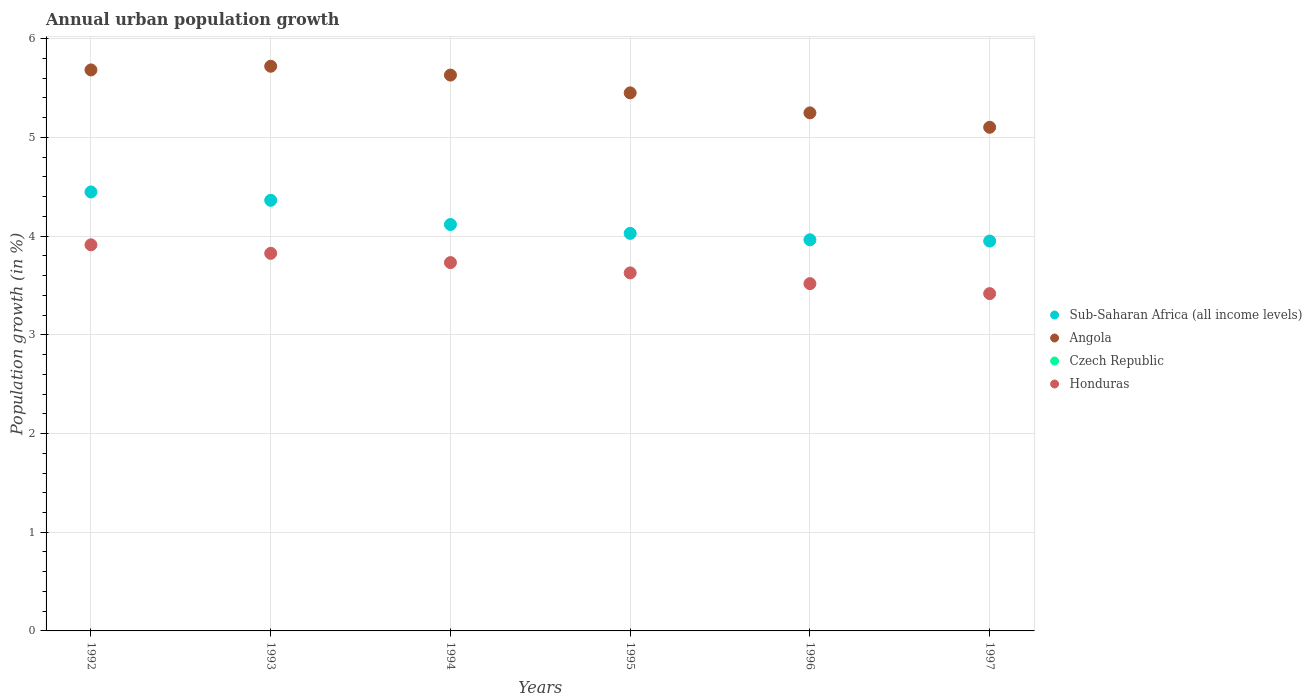Is the number of dotlines equal to the number of legend labels?
Offer a terse response. No. What is the percentage of urban population growth in Honduras in 1992?
Make the answer very short. 3.91. Across all years, what is the maximum percentage of urban population growth in Sub-Saharan Africa (all income levels)?
Keep it short and to the point. 4.45. Across all years, what is the minimum percentage of urban population growth in Czech Republic?
Ensure brevity in your answer.  0. In which year was the percentage of urban population growth in Angola maximum?
Your response must be concise. 1993. What is the total percentage of urban population growth in Sub-Saharan Africa (all income levels) in the graph?
Offer a terse response. 24.87. What is the difference between the percentage of urban population growth in Angola in 1993 and that in 1995?
Your answer should be compact. 0.27. What is the difference between the percentage of urban population growth in Sub-Saharan Africa (all income levels) in 1994 and the percentage of urban population growth in Honduras in 1996?
Offer a very short reply. 0.6. What is the average percentage of urban population growth in Honduras per year?
Keep it short and to the point. 3.67. In the year 1995, what is the difference between the percentage of urban population growth in Angola and percentage of urban population growth in Honduras?
Offer a very short reply. 1.82. What is the ratio of the percentage of urban population growth in Sub-Saharan Africa (all income levels) in 1994 to that in 1996?
Offer a terse response. 1.04. Is the difference between the percentage of urban population growth in Angola in 1992 and 1994 greater than the difference between the percentage of urban population growth in Honduras in 1992 and 1994?
Make the answer very short. No. What is the difference between the highest and the second highest percentage of urban population growth in Honduras?
Provide a short and direct response. 0.09. What is the difference between the highest and the lowest percentage of urban population growth in Angola?
Offer a very short reply. 0.62. Is it the case that in every year, the sum of the percentage of urban population growth in Honduras and percentage of urban population growth in Sub-Saharan Africa (all income levels)  is greater than the percentage of urban population growth in Angola?
Keep it short and to the point. Yes. Does the percentage of urban population growth in Honduras monotonically increase over the years?
Keep it short and to the point. No. How many dotlines are there?
Your answer should be very brief. 3. What is the difference between two consecutive major ticks on the Y-axis?
Your answer should be compact. 1. What is the title of the graph?
Provide a succinct answer. Annual urban population growth. Does "Aruba" appear as one of the legend labels in the graph?
Your answer should be very brief. No. What is the label or title of the Y-axis?
Your answer should be compact. Population growth (in %). What is the Population growth (in %) of Sub-Saharan Africa (all income levels) in 1992?
Offer a terse response. 4.45. What is the Population growth (in %) of Angola in 1992?
Provide a succinct answer. 5.68. What is the Population growth (in %) in Honduras in 1992?
Ensure brevity in your answer.  3.91. What is the Population growth (in %) of Sub-Saharan Africa (all income levels) in 1993?
Offer a very short reply. 4.36. What is the Population growth (in %) in Angola in 1993?
Your answer should be very brief. 5.72. What is the Population growth (in %) in Honduras in 1993?
Give a very brief answer. 3.83. What is the Population growth (in %) of Sub-Saharan Africa (all income levels) in 1994?
Offer a very short reply. 4.12. What is the Population growth (in %) of Angola in 1994?
Offer a terse response. 5.63. What is the Population growth (in %) in Honduras in 1994?
Your answer should be compact. 3.73. What is the Population growth (in %) of Sub-Saharan Africa (all income levels) in 1995?
Your response must be concise. 4.03. What is the Population growth (in %) in Angola in 1995?
Make the answer very short. 5.45. What is the Population growth (in %) in Czech Republic in 1995?
Make the answer very short. 0. What is the Population growth (in %) in Honduras in 1995?
Provide a short and direct response. 3.63. What is the Population growth (in %) in Sub-Saharan Africa (all income levels) in 1996?
Provide a short and direct response. 3.96. What is the Population growth (in %) of Angola in 1996?
Ensure brevity in your answer.  5.25. What is the Population growth (in %) of Czech Republic in 1996?
Provide a succinct answer. 0. What is the Population growth (in %) of Honduras in 1996?
Give a very brief answer. 3.52. What is the Population growth (in %) of Sub-Saharan Africa (all income levels) in 1997?
Provide a short and direct response. 3.95. What is the Population growth (in %) of Angola in 1997?
Ensure brevity in your answer.  5.1. What is the Population growth (in %) in Honduras in 1997?
Offer a terse response. 3.42. Across all years, what is the maximum Population growth (in %) in Sub-Saharan Africa (all income levels)?
Your response must be concise. 4.45. Across all years, what is the maximum Population growth (in %) in Angola?
Ensure brevity in your answer.  5.72. Across all years, what is the maximum Population growth (in %) in Honduras?
Your answer should be very brief. 3.91. Across all years, what is the minimum Population growth (in %) in Sub-Saharan Africa (all income levels)?
Your response must be concise. 3.95. Across all years, what is the minimum Population growth (in %) in Angola?
Keep it short and to the point. 5.1. Across all years, what is the minimum Population growth (in %) of Honduras?
Give a very brief answer. 3.42. What is the total Population growth (in %) of Sub-Saharan Africa (all income levels) in the graph?
Provide a short and direct response. 24.87. What is the total Population growth (in %) in Angola in the graph?
Your response must be concise. 32.84. What is the total Population growth (in %) in Czech Republic in the graph?
Your answer should be very brief. 0. What is the total Population growth (in %) in Honduras in the graph?
Keep it short and to the point. 22.03. What is the difference between the Population growth (in %) of Sub-Saharan Africa (all income levels) in 1992 and that in 1993?
Make the answer very short. 0.08. What is the difference between the Population growth (in %) in Angola in 1992 and that in 1993?
Your response must be concise. -0.04. What is the difference between the Population growth (in %) of Honduras in 1992 and that in 1993?
Keep it short and to the point. 0.09. What is the difference between the Population growth (in %) in Sub-Saharan Africa (all income levels) in 1992 and that in 1994?
Your answer should be compact. 0.33. What is the difference between the Population growth (in %) of Angola in 1992 and that in 1994?
Keep it short and to the point. 0.05. What is the difference between the Population growth (in %) of Honduras in 1992 and that in 1994?
Keep it short and to the point. 0.18. What is the difference between the Population growth (in %) of Sub-Saharan Africa (all income levels) in 1992 and that in 1995?
Make the answer very short. 0.42. What is the difference between the Population growth (in %) of Angola in 1992 and that in 1995?
Offer a terse response. 0.23. What is the difference between the Population growth (in %) of Honduras in 1992 and that in 1995?
Keep it short and to the point. 0.28. What is the difference between the Population growth (in %) in Sub-Saharan Africa (all income levels) in 1992 and that in 1996?
Offer a terse response. 0.48. What is the difference between the Population growth (in %) of Angola in 1992 and that in 1996?
Your response must be concise. 0.44. What is the difference between the Population growth (in %) in Honduras in 1992 and that in 1996?
Provide a succinct answer. 0.39. What is the difference between the Population growth (in %) in Sub-Saharan Africa (all income levels) in 1992 and that in 1997?
Keep it short and to the point. 0.5. What is the difference between the Population growth (in %) in Angola in 1992 and that in 1997?
Your response must be concise. 0.58. What is the difference between the Population growth (in %) in Honduras in 1992 and that in 1997?
Ensure brevity in your answer.  0.49. What is the difference between the Population growth (in %) of Sub-Saharan Africa (all income levels) in 1993 and that in 1994?
Keep it short and to the point. 0.25. What is the difference between the Population growth (in %) of Angola in 1993 and that in 1994?
Make the answer very short. 0.09. What is the difference between the Population growth (in %) of Honduras in 1993 and that in 1994?
Provide a short and direct response. 0.09. What is the difference between the Population growth (in %) of Sub-Saharan Africa (all income levels) in 1993 and that in 1995?
Your response must be concise. 0.34. What is the difference between the Population growth (in %) in Angola in 1993 and that in 1995?
Your answer should be very brief. 0.27. What is the difference between the Population growth (in %) of Honduras in 1993 and that in 1995?
Your answer should be very brief. 0.2. What is the difference between the Population growth (in %) of Sub-Saharan Africa (all income levels) in 1993 and that in 1996?
Your answer should be compact. 0.4. What is the difference between the Population growth (in %) of Angola in 1993 and that in 1996?
Give a very brief answer. 0.47. What is the difference between the Population growth (in %) in Honduras in 1993 and that in 1996?
Keep it short and to the point. 0.31. What is the difference between the Population growth (in %) in Sub-Saharan Africa (all income levels) in 1993 and that in 1997?
Offer a very short reply. 0.41. What is the difference between the Population growth (in %) of Angola in 1993 and that in 1997?
Make the answer very short. 0.62. What is the difference between the Population growth (in %) in Honduras in 1993 and that in 1997?
Your response must be concise. 0.41. What is the difference between the Population growth (in %) of Sub-Saharan Africa (all income levels) in 1994 and that in 1995?
Your answer should be very brief. 0.09. What is the difference between the Population growth (in %) of Angola in 1994 and that in 1995?
Your response must be concise. 0.18. What is the difference between the Population growth (in %) in Honduras in 1994 and that in 1995?
Offer a very short reply. 0.1. What is the difference between the Population growth (in %) in Sub-Saharan Africa (all income levels) in 1994 and that in 1996?
Your response must be concise. 0.15. What is the difference between the Population growth (in %) of Angola in 1994 and that in 1996?
Provide a succinct answer. 0.38. What is the difference between the Population growth (in %) of Honduras in 1994 and that in 1996?
Your answer should be very brief. 0.21. What is the difference between the Population growth (in %) in Sub-Saharan Africa (all income levels) in 1994 and that in 1997?
Ensure brevity in your answer.  0.17. What is the difference between the Population growth (in %) in Angola in 1994 and that in 1997?
Make the answer very short. 0.53. What is the difference between the Population growth (in %) in Honduras in 1994 and that in 1997?
Your answer should be compact. 0.31. What is the difference between the Population growth (in %) in Sub-Saharan Africa (all income levels) in 1995 and that in 1996?
Provide a succinct answer. 0.06. What is the difference between the Population growth (in %) of Angola in 1995 and that in 1996?
Offer a very short reply. 0.2. What is the difference between the Population growth (in %) of Honduras in 1995 and that in 1996?
Ensure brevity in your answer.  0.11. What is the difference between the Population growth (in %) of Sub-Saharan Africa (all income levels) in 1995 and that in 1997?
Give a very brief answer. 0.08. What is the difference between the Population growth (in %) in Angola in 1995 and that in 1997?
Your response must be concise. 0.35. What is the difference between the Population growth (in %) in Honduras in 1995 and that in 1997?
Offer a very short reply. 0.21. What is the difference between the Population growth (in %) of Sub-Saharan Africa (all income levels) in 1996 and that in 1997?
Your answer should be compact. 0.01. What is the difference between the Population growth (in %) in Angola in 1996 and that in 1997?
Provide a short and direct response. 0.15. What is the difference between the Population growth (in %) in Honduras in 1996 and that in 1997?
Offer a very short reply. 0.1. What is the difference between the Population growth (in %) of Sub-Saharan Africa (all income levels) in 1992 and the Population growth (in %) of Angola in 1993?
Your answer should be very brief. -1.27. What is the difference between the Population growth (in %) of Sub-Saharan Africa (all income levels) in 1992 and the Population growth (in %) of Honduras in 1993?
Ensure brevity in your answer.  0.62. What is the difference between the Population growth (in %) in Angola in 1992 and the Population growth (in %) in Honduras in 1993?
Your answer should be compact. 1.86. What is the difference between the Population growth (in %) in Sub-Saharan Africa (all income levels) in 1992 and the Population growth (in %) in Angola in 1994?
Offer a terse response. -1.18. What is the difference between the Population growth (in %) of Sub-Saharan Africa (all income levels) in 1992 and the Population growth (in %) of Honduras in 1994?
Provide a short and direct response. 0.72. What is the difference between the Population growth (in %) in Angola in 1992 and the Population growth (in %) in Honduras in 1994?
Offer a terse response. 1.95. What is the difference between the Population growth (in %) of Sub-Saharan Africa (all income levels) in 1992 and the Population growth (in %) of Angola in 1995?
Your answer should be compact. -1. What is the difference between the Population growth (in %) in Sub-Saharan Africa (all income levels) in 1992 and the Population growth (in %) in Honduras in 1995?
Your answer should be compact. 0.82. What is the difference between the Population growth (in %) of Angola in 1992 and the Population growth (in %) of Honduras in 1995?
Provide a succinct answer. 2.06. What is the difference between the Population growth (in %) in Sub-Saharan Africa (all income levels) in 1992 and the Population growth (in %) in Angola in 1996?
Provide a short and direct response. -0.8. What is the difference between the Population growth (in %) in Sub-Saharan Africa (all income levels) in 1992 and the Population growth (in %) in Honduras in 1996?
Provide a short and direct response. 0.93. What is the difference between the Population growth (in %) of Angola in 1992 and the Population growth (in %) of Honduras in 1996?
Your answer should be very brief. 2.17. What is the difference between the Population growth (in %) in Sub-Saharan Africa (all income levels) in 1992 and the Population growth (in %) in Angola in 1997?
Offer a very short reply. -0.66. What is the difference between the Population growth (in %) of Angola in 1992 and the Population growth (in %) of Honduras in 1997?
Ensure brevity in your answer.  2.27. What is the difference between the Population growth (in %) of Sub-Saharan Africa (all income levels) in 1993 and the Population growth (in %) of Angola in 1994?
Ensure brevity in your answer.  -1.27. What is the difference between the Population growth (in %) in Sub-Saharan Africa (all income levels) in 1993 and the Population growth (in %) in Honduras in 1994?
Your answer should be compact. 0.63. What is the difference between the Population growth (in %) in Angola in 1993 and the Population growth (in %) in Honduras in 1994?
Your answer should be very brief. 1.99. What is the difference between the Population growth (in %) of Sub-Saharan Africa (all income levels) in 1993 and the Population growth (in %) of Angola in 1995?
Make the answer very short. -1.09. What is the difference between the Population growth (in %) of Sub-Saharan Africa (all income levels) in 1993 and the Population growth (in %) of Honduras in 1995?
Make the answer very short. 0.74. What is the difference between the Population growth (in %) in Angola in 1993 and the Population growth (in %) in Honduras in 1995?
Your response must be concise. 2.09. What is the difference between the Population growth (in %) of Sub-Saharan Africa (all income levels) in 1993 and the Population growth (in %) of Angola in 1996?
Provide a short and direct response. -0.89. What is the difference between the Population growth (in %) in Sub-Saharan Africa (all income levels) in 1993 and the Population growth (in %) in Honduras in 1996?
Provide a succinct answer. 0.84. What is the difference between the Population growth (in %) in Angola in 1993 and the Population growth (in %) in Honduras in 1996?
Offer a terse response. 2.2. What is the difference between the Population growth (in %) of Sub-Saharan Africa (all income levels) in 1993 and the Population growth (in %) of Angola in 1997?
Your answer should be very brief. -0.74. What is the difference between the Population growth (in %) of Sub-Saharan Africa (all income levels) in 1993 and the Population growth (in %) of Honduras in 1997?
Your response must be concise. 0.95. What is the difference between the Population growth (in %) of Angola in 1993 and the Population growth (in %) of Honduras in 1997?
Provide a succinct answer. 2.3. What is the difference between the Population growth (in %) of Sub-Saharan Africa (all income levels) in 1994 and the Population growth (in %) of Angola in 1995?
Your response must be concise. -1.33. What is the difference between the Population growth (in %) of Sub-Saharan Africa (all income levels) in 1994 and the Population growth (in %) of Honduras in 1995?
Keep it short and to the point. 0.49. What is the difference between the Population growth (in %) in Angola in 1994 and the Population growth (in %) in Honduras in 1995?
Offer a terse response. 2. What is the difference between the Population growth (in %) in Sub-Saharan Africa (all income levels) in 1994 and the Population growth (in %) in Angola in 1996?
Keep it short and to the point. -1.13. What is the difference between the Population growth (in %) in Sub-Saharan Africa (all income levels) in 1994 and the Population growth (in %) in Honduras in 1996?
Provide a short and direct response. 0.6. What is the difference between the Population growth (in %) in Angola in 1994 and the Population growth (in %) in Honduras in 1996?
Offer a terse response. 2.11. What is the difference between the Population growth (in %) of Sub-Saharan Africa (all income levels) in 1994 and the Population growth (in %) of Angola in 1997?
Your answer should be compact. -0.98. What is the difference between the Population growth (in %) in Sub-Saharan Africa (all income levels) in 1994 and the Population growth (in %) in Honduras in 1997?
Your answer should be very brief. 0.7. What is the difference between the Population growth (in %) of Angola in 1994 and the Population growth (in %) of Honduras in 1997?
Offer a very short reply. 2.21. What is the difference between the Population growth (in %) in Sub-Saharan Africa (all income levels) in 1995 and the Population growth (in %) in Angola in 1996?
Offer a very short reply. -1.22. What is the difference between the Population growth (in %) of Sub-Saharan Africa (all income levels) in 1995 and the Population growth (in %) of Honduras in 1996?
Your response must be concise. 0.51. What is the difference between the Population growth (in %) in Angola in 1995 and the Population growth (in %) in Honduras in 1996?
Your answer should be very brief. 1.93. What is the difference between the Population growth (in %) in Sub-Saharan Africa (all income levels) in 1995 and the Population growth (in %) in Angola in 1997?
Provide a short and direct response. -1.07. What is the difference between the Population growth (in %) in Sub-Saharan Africa (all income levels) in 1995 and the Population growth (in %) in Honduras in 1997?
Offer a terse response. 0.61. What is the difference between the Population growth (in %) in Angola in 1995 and the Population growth (in %) in Honduras in 1997?
Offer a terse response. 2.03. What is the difference between the Population growth (in %) of Sub-Saharan Africa (all income levels) in 1996 and the Population growth (in %) of Angola in 1997?
Your answer should be compact. -1.14. What is the difference between the Population growth (in %) in Sub-Saharan Africa (all income levels) in 1996 and the Population growth (in %) in Honduras in 1997?
Offer a terse response. 0.55. What is the difference between the Population growth (in %) of Angola in 1996 and the Population growth (in %) of Honduras in 1997?
Your answer should be compact. 1.83. What is the average Population growth (in %) of Sub-Saharan Africa (all income levels) per year?
Your answer should be very brief. 4.14. What is the average Population growth (in %) in Angola per year?
Your answer should be compact. 5.47. What is the average Population growth (in %) of Czech Republic per year?
Give a very brief answer. 0. What is the average Population growth (in %) of Honduras per year?
Offer a very short reply. 3.67. In the year 1992, what is the difference between the Population growth (in %) of Sub-Saharan Africa (all income levels) and Population growth (in %) of Angola?
Your answer should be compact. -1.24. In the year 1992, what is the difference between the Population growth (in %) of Sub-Saharan Africa (all income levels) and Population growth (in %) of Honduras?
Give a very brief answer. 0.54. In the year 1992, what is the difference between the Population growth (in %) in Angola and Population growth (in %) in Honduras?
Your answer should be compact. 1.77. In the year 1993, what is the difference between the Population growth (in %) of Sub-Saharan Africa (all income levels) and Population growth (in %) of Angola?
Your answer should be very brief. -1.36. In the year 1993, what is the difference between the Population growth (in %) of Sub-Saharan Africa (all income levels) and Population growth (in %) of Honduras?
Your answer should be very brief. 0.54. In the year 1993, what is the difference between the Population growth (in %) in Angola and Population growth (in %) in Honduras?
Your answer should be very brief. 1.9. In the year 1994, what is the difference between the Population growth (in %) in Sub-Saharan Africa (all income levels) and Population growth (in %) in Angola?
Your answer should be very brief. -1.51. In the year 1994, what is the difference between the Population growth (in %) in Sub-Saharan Africa (all income levels) and Population growth (in %) in Honduras?
Keep it short and to the point. 0.39. In the year 1995, what is the difference between the Population growth (in %) of Sub-Saharan Africa (all income levels) and Population growth (in %) of Angola?
Provide a short and direct response. -1.42. In the year 1995, what is the difference between the Population growth (in %) in Sub-Saharan Africa (all income levels) and Population growth (in %) in Honduras?
Offer a very short reply. 0.4. In the year 1995, what is the difference between the Population growth (in %) in Angola and Population growth (in %) in Honduras?
Provide a short and direct response. 1.82. In the year 1996, what is the difference between the Population growth (in %) of Sub-Saharan Africa (all income levels) and Population growth (in %) of Angola?
Offer a very short reply. -1.29. In the year 1996, what is the difference between the Population growth (in %) in Sub-Saharan Africa (all income levels) and Population growth (in %) in Honduras?
Offer a very short reply. 0.44. In the year 1996, what is the difference between the Population growth (in %) of Angola and Population growth (in %) of Honduras?
Offer a terse response. 1.73. In the year 1997, what is the difference between the Population growth (in %) of Sub-Saharan Africa (all income levels) and Population growth (in %) of Angola?
Offer a very short reply. -1.15. In the year 1997, what is the difference between the Population growth (in %) in Sub-Saharan Africa (all income levels) and Population growth (in %) in Honduras?
Provide a short and direct response. 0.53. In the year 1997, what is the difference between the Population growth (in %) in Angola and Population growth (in %) in Honduras?
Provide a succinct answer. 1.69. What is the ratio of the Population growth (in %) of Sub-Saharan Africa (all income levels) in 1992 to that in 1993?
Ensure brevity in your answer.  1.02. What is the ratio of the Population growth (in %) in Angola in 1992 to that in 1993?
Keep it short and to the point. 0.99. What is the ratio of the Population growth (in %) in Honduras in 1992 to that in 1993?
Ensure brevity in your answer.  1.02. What is the ratio of the Population growth (in %) in Angola in 1992 to that in 1994?
Make the answer very short. 1.01. What is the ratio of the Population growth (in %) of Honduras in 1992 to that in 1994?
Make the answer very short. 1.05. What is the ratio of the Population growth (in %) of Sub-Saharan Africa (all income levels) in 1992 to that in 1995?
Your answer should be very brief. 1.1. What is the ratio of the Population growth (in %) of Angola in 1992 to that in 1995?
Provide a short and direct response. 1.04. What is the ratio of the Population growth (in %) in Honduras in 1992 to that in 1995?
Offer a terse response. 1.08. What is the ratio of the Population growth (in %) of Sub-Saharan Africa (all income levels) in 1992 to that in 1996?
Keep it short and to the point. 1.12. What is the ratio of the Population growth (in %) of Angola in 1992 to that in 1996?
Provide a succinct answer. 1.08. What is the ratio of the Population growth (in %) in Honduras in 1992 to that in 1996?
Your answer should be very brief. 1.11. What is the ratio of the Population growth (in %) in Sub-Saharan Africa (all income levels) in 1992 to that in 1997?
Give a very brief answer. 1.13. What is the ratio of the Population growth (in %) of Angola in 1992 to that in 1997?
Make the answer very short. 1.11. What is the ratio of the Population growth (in %) in Honduras in 1992 to that in 1997?
Make the answer very short. 1.14. What is the ratio of the Population growth (in %) in Sub-Saharan Africa (all income levels) in 1993 to that in 1994?
Offer a very short reply. 1.06. What is the ratio of the Population growth (in %) of Angola in 1993 to that in 1994?
Make the answer very short. 1.02. What is the ratio of the Population growth (in %) in Honduras in 1993 to that in 1994?
Your answer should be compact. 1.03. What is the ratio of the Population growth (in %) of Sub-Saharan Africa (all income levels) in 1993 to that in 1995?
Provide a short and direct response. 1.08. What is the ratio of the Population growth (in %) in Angola in 1993 to that in 1995?
Provide a succinct answer. 1.05. What is the ratio of the Population growth (in %) of Honduras in 1993 to that in 1995?
Your answer should be very brief. 1.05. What is the ratio of the Population growth (in %) of Sub-Saharan Africa (all income levels) in 1993 to that in 1996?
Offer a very short reply. 1.1. What is the ratio of the Population growth (in %) of Angola in 1993 to that in 1996?
Your answer should be compact. 1.09. What is the ratio of the Population growth (in %) of Honduras in 1993 to that in 1996?
Make the answer very short. 1.09. What is the ratio of the Population growth (in %) of Sub-Saharan Africa (all income levels) in 1993 to that in 1997?
Keep it short and to the point. 1.1. What is the ratio of the Population growth (in %) of Angola in 1993 to that in 1997?
Your answer should be very brief. 1.12. What is the ratio of the Population growth (in %) in Honduras in 1993 to that in 1997?
Ensure brevity in your answer.  1.12. What is the ratio of the Population growth (in %) of Sub-Saharan Africa (all income levels) in 1994 to that in 1995?
Provide a short and direct response. 1.02. What is the ratio of the Population growth (in %) in Angola in 1994 to that in 1995?
Your response must be concise. 1.03. What is the ratio of the Population growth (in %) of Honduras in 1994 to that in 1995?
Your answer should be compact. 1.03. What is the ratio of the Population growth (in %) of Sub-Saharan Africa (all income levels) in 1994 to that in 1996?
Your answer should be very brief. 1.04. What is the ratio of the Population growth (in %) in Angola in 1994 to that in 1996?
Offer a very short reply. 1.07. What is the ratio of the Population growth (in %) of Honduras in 1994 to that in 1996?
Your answer should be compact. 1.06. What is the ratio of the Population growth (in %) of Sub-Saharan Africa (all income levels) in 1994 to that in 1997?
Your response must be concise. 1.04. What is the ratio of the Population growth (in %) in Angola in 1994 to that in 1997?
Provide a short and direct response. 1.1. What is the ratio of the Population growth (in %) in Honduras in 1994 to that in 1997?
Your answer should be very brief. 1.09. What is the ratio of the Population growth (in %) of Sub-Saharan Africa (all income levels) in 1995 to that in 1996?
Provide a succinct answer. 1.02. What is the ratio of the Population growth (in %) in Angola in 1995 to that in 1996?
Give a very brief answer. 1.04. What is the ratio of the Population growth (in %) of Honduras in 1995 to that in 1996?
Offer a terse response. 1.03. What is the ratio of the Population growth (in %) in Sub-Saharan Africa (all income levels) in 1995 to that in 1997?
Ensure brevity in your answer.  1.02. What is the ratio of the Population growth (in %) of Angola in 1995 to that in 1997?
Provide a succinct answer. 1.07. What is the ratio of the Population growth (in %) in Honduras in 1995 to that in 1997?
Give a very brief answer. 1.06. What is the ratio of the Population growth (in %) of Angola in 1996 to that in 1997?
Ensure brevity in your answer.  1.03. What is the ratio of the Population growth (in %) of Honduras in 1996 to that in 1997?
Give a very brief answer. 1.03. What is the difference between the highest and the second highest Population growth (in %) in Sub-Saharan Africa (all income levels)?
Keep it short and to the point. 0.08. What is the difference between the highest and the second highest Population growth (in %) in Angola?
Make the answer very short. 0.04. What is the difference between the highest and the second highest Population growth (in %) of Honduras?
Offer a terse response. 0.09. What is the difference between the highest and the lowest Population growth (in %) of Sub-Saharan Africa (all income levels)?
Keep it short and to the point. 0.5. What is the difference between the highest and the lowest Population growth (in %) of Angola?
Keep it short and to the point. 0.62. What is the difference between the highest and the lowest Population growth (in %) of Honduras?
Your answer should be compact. 0.49. 